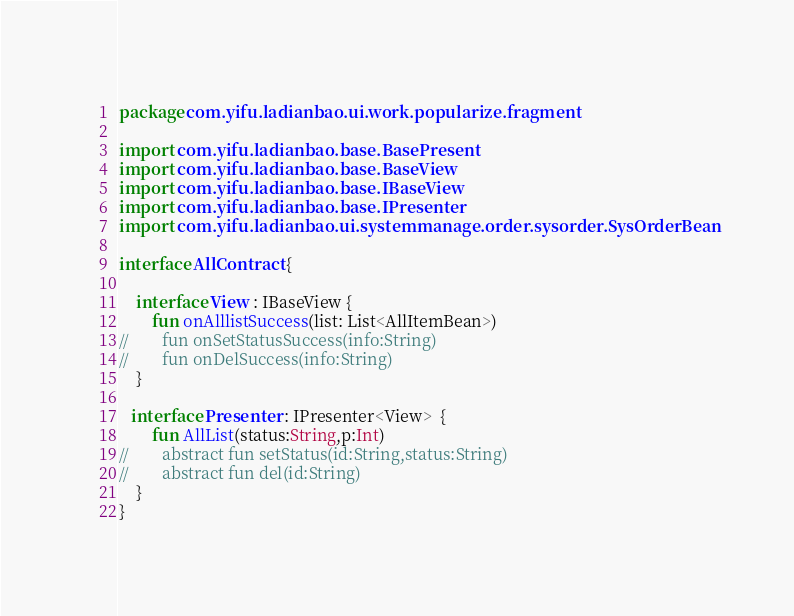<code> <loc_0><loc_0><loc_500><loc_500><_Kotlin_>package com.yifu.ladianbao.ui.work.popularize.fragment

import com.yifu.ladianbao.base.BasePresent
import com.yifu.ladianbao.base.BaseView
import com.yifu.ladianbao.base.IBaseView
import com.yifu.ladianbao.base.IPresenter
import com.yifu.ladianbao.ui.systemmanage.order.sysorder.SysOrderBean

interface AllContract {

    interface View : IBaseView {
        fun onAlllistSuccess(list: List<AllItemBean>)
//        fun onSetStatusSuccess(info:String)
//        fun onDelSuccess(info:String)
    }

   interface Presenter : IPresenter<View>  {
        fun AllList(status:String,p:Int)
//        abstract fun setStatus(id:String,status:String)
//        abstract fun del(id:String)
    }
}</code> 